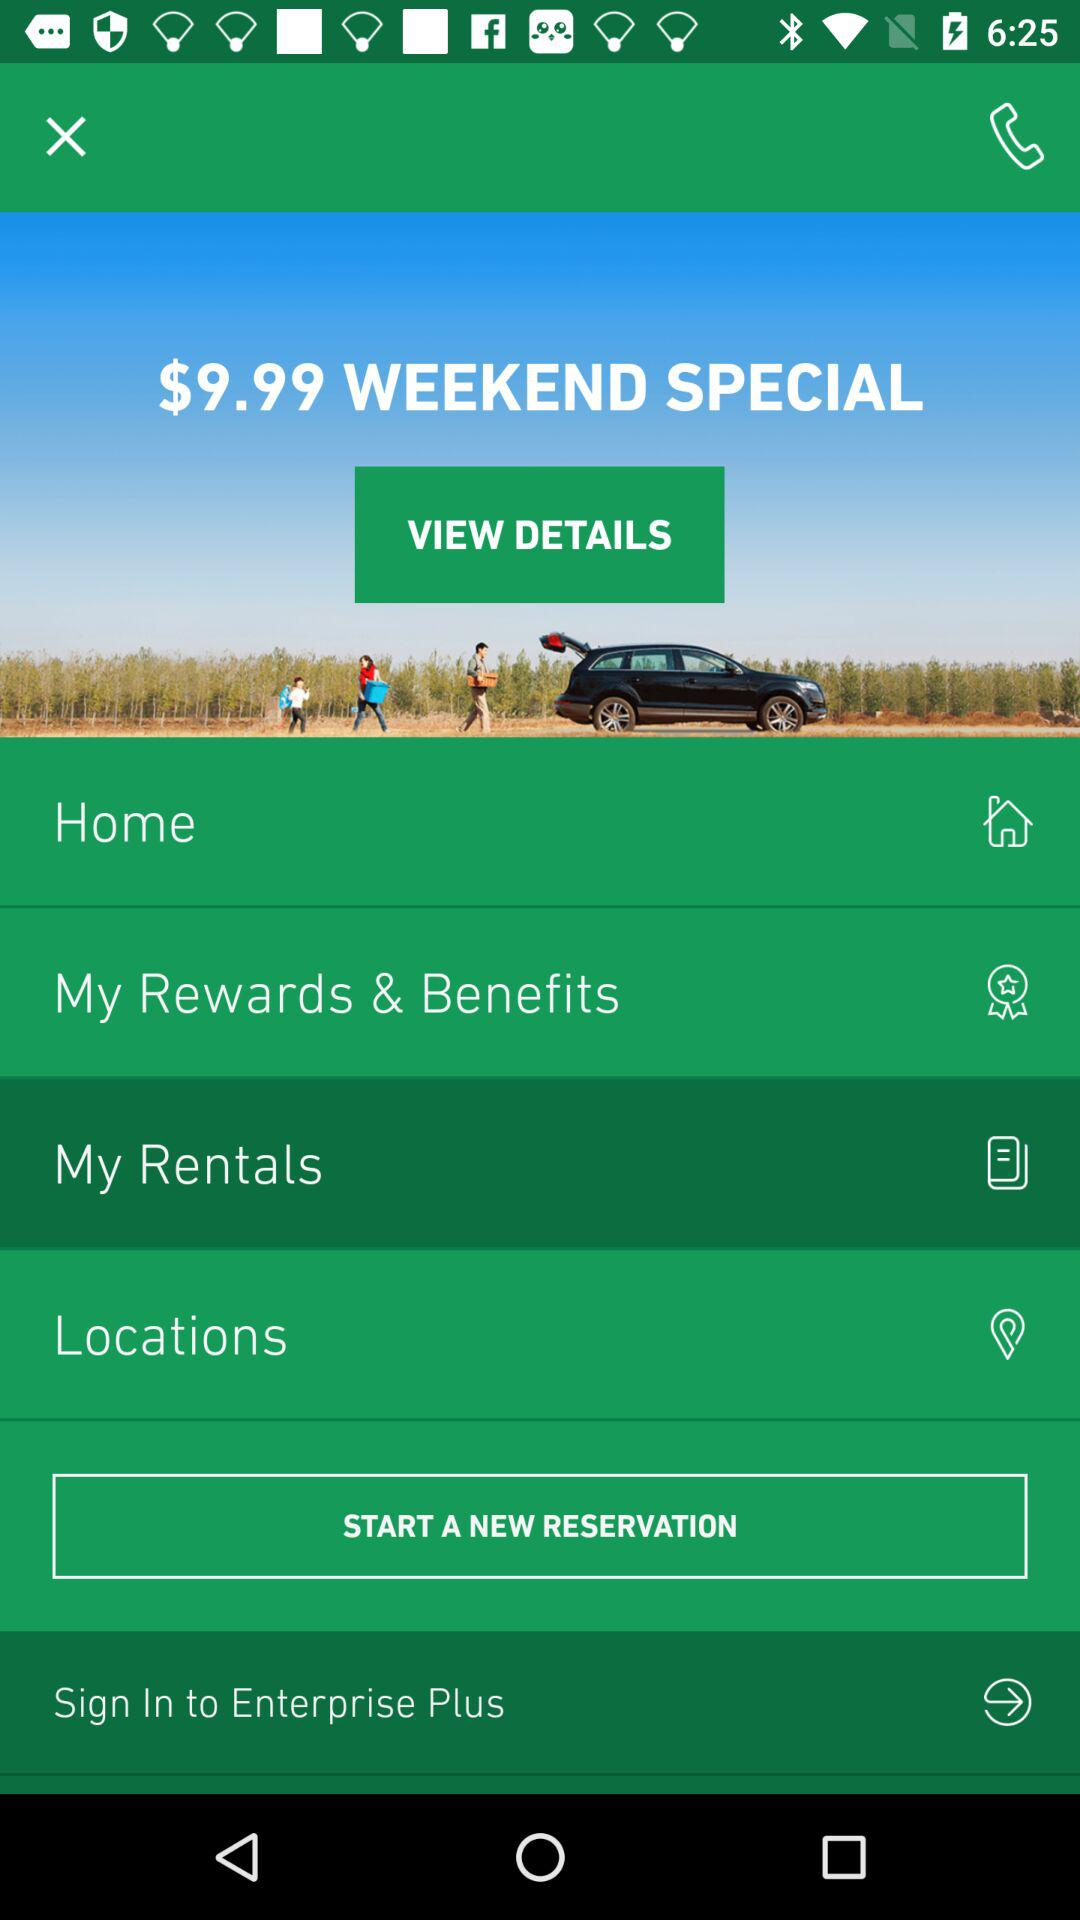What is the weekend special price? The weekend special price is $9.99. 